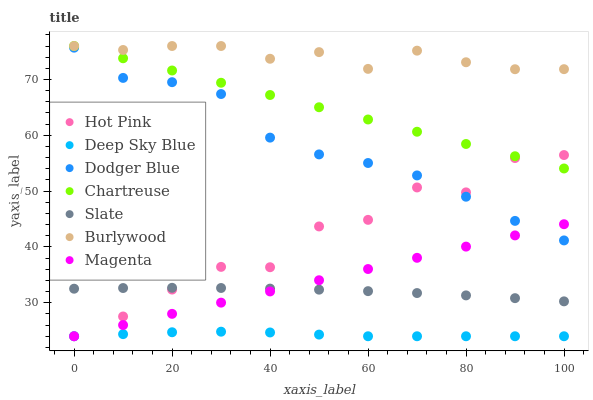Does Deep Sky Blue have the minimum area under the curve?
Answer yes or no. Yes. Does Burlywood have the maximum area under the curve?
Answer yes or no. Yes. Does Slate have the minimum area under the curve?
Answer yes or no. No. Does Slate have the maximum area under the curve?
Answer yes or no. No. Is Magenta the smoothest?
Answer yes or no. Yes. Is Hot Pink the roughest?
Answer yes or no. Yes. Is Slate the smoothest?
Answer yes or no. No. Is Slate the roughest?
Answer yes or no. No. Does Hot Pink have the lowest value?
Answer yes or no. Yes. Does Slate have the lowest value?
Answer yes or no. No. Does Chartreuse have the highest value?
Answer yes or no. Yes. Does Slate have the highest value?
Answer yes or no. No. Is Deep Sky Blue less than Burlywood?
Answer yes or no. Yes. Is Chartreuse greater than Dodger Blue?
Answer yes or no. Yes. Does Magenta intersect Dodger Blue?
Answer yes or no. Yes. Is Magenta less than Dodger Blue?
Answer yes or no. No. Is Magenta greater than Dodger Blue?
Answer yes or no. No. Does Deep Sky Blue intersect Burlywood?
Answer yes or no. No. 